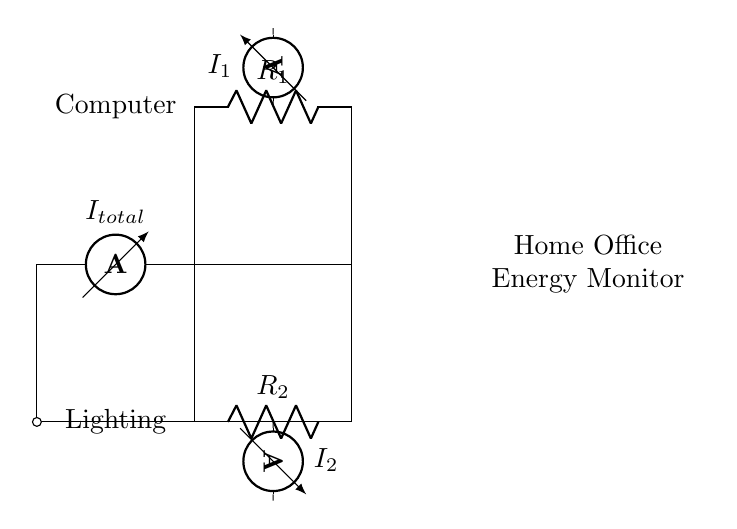What is the total current flowing in the circuit? The total current is represented by the ammeter labeled as I_total at the start of the circuit. It measures the combined current flowing through the circuit.
Answer: I_total What are the values of the resistors in the circuit? The resistors are labeled R_1 and R_2, but their specific values are not provided in the diagram. The diagram only indicates their presence for current division without numerical values.
Answer: Not specified How many branches does the current divide into? The circuit diagram shows two branches where the total current I_total is divided, going through resistors R_1 and R_2. Each branch has a dedicated current measurement (I_1 and I_2).
Answer: Two What is the significance of the ammeters in this circuit? The ammeters measure the current flowing through each branch of the circuit, allowing for monitoring the energy consumption of the devices connected to those branches: the computer and lighting.
Answer: Current measurement How does the current divide between R_1 and R_2? The current divides according to the resistor values. According to Ohm's law, the current will be inversely proportional to the resistance, meaning the lower the resistance, the higher the current through that branch.
Answer: Inversely proportional to resistance Which device does R_1 represent in the circuit? The diagram explicitly labels R_1 as connected to the "Computer," indicating that this resistor is the load for the computer's energy consumption in the home office setup.
Answer: Computer Which device does R_2 represent in the circuit? The diagram labels R_2 as connected to “Lighting,” indicating that this resistor is used to represent the energy consumption of the lighting in the home office.
Answer: Lighting 